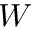<formula> <loc_0><loc_0><loc_500><loc_500>W</formula> 